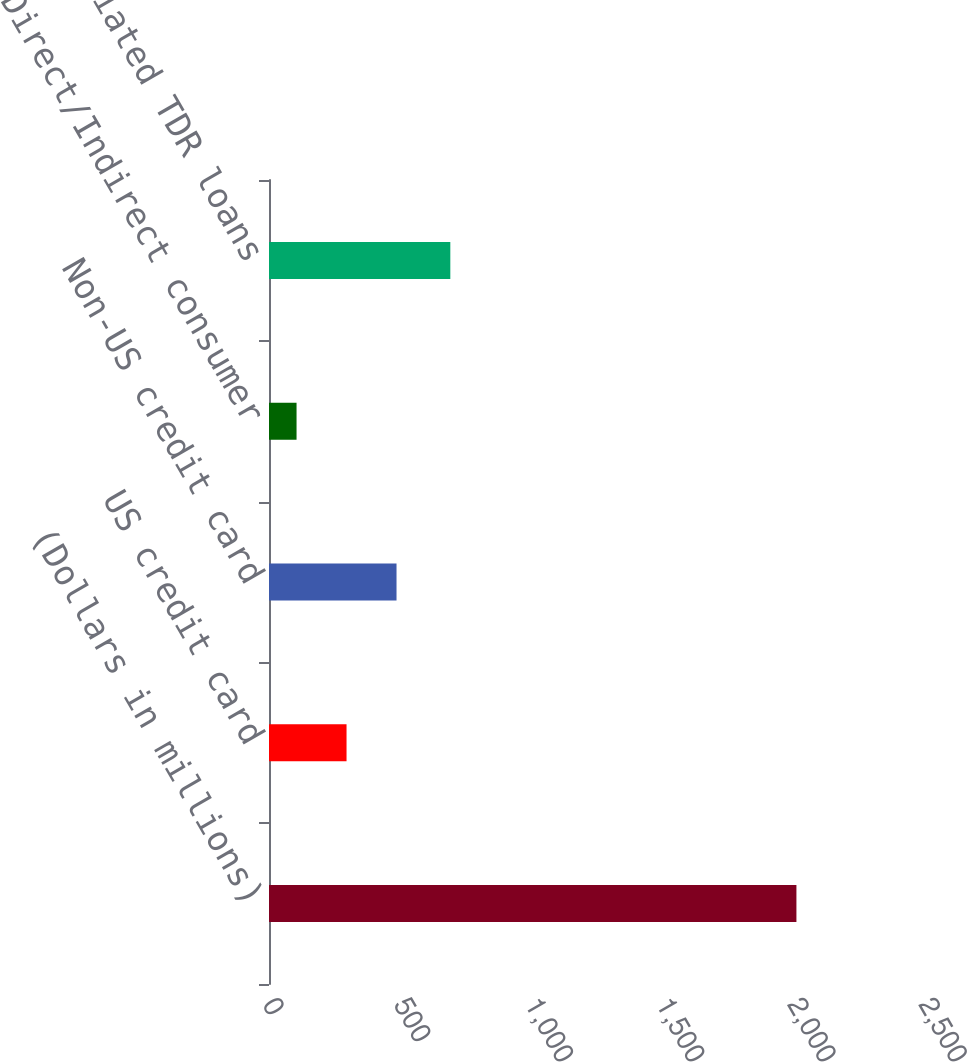Convert chart. <chart><loc_0><loc_0><loc_500><loc_500><bar_chart><fcel>(Dollars in millions)<fcel>US credit card<fcel>Non-US credit card<fcel>Direct/Indirect consumer<fcel>Total renegotiated TDR loans<nl><fcel>2010<fcel>295.5<fcel>486<fcel>105<fcel>691<nl></chart> 